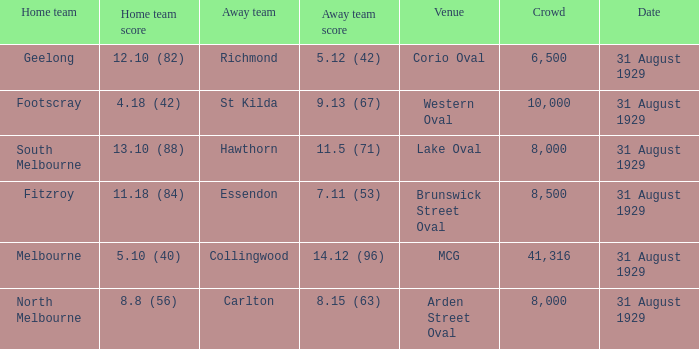What has been the biggest audience for a match with hawthorn as the away team? 8000.0. 